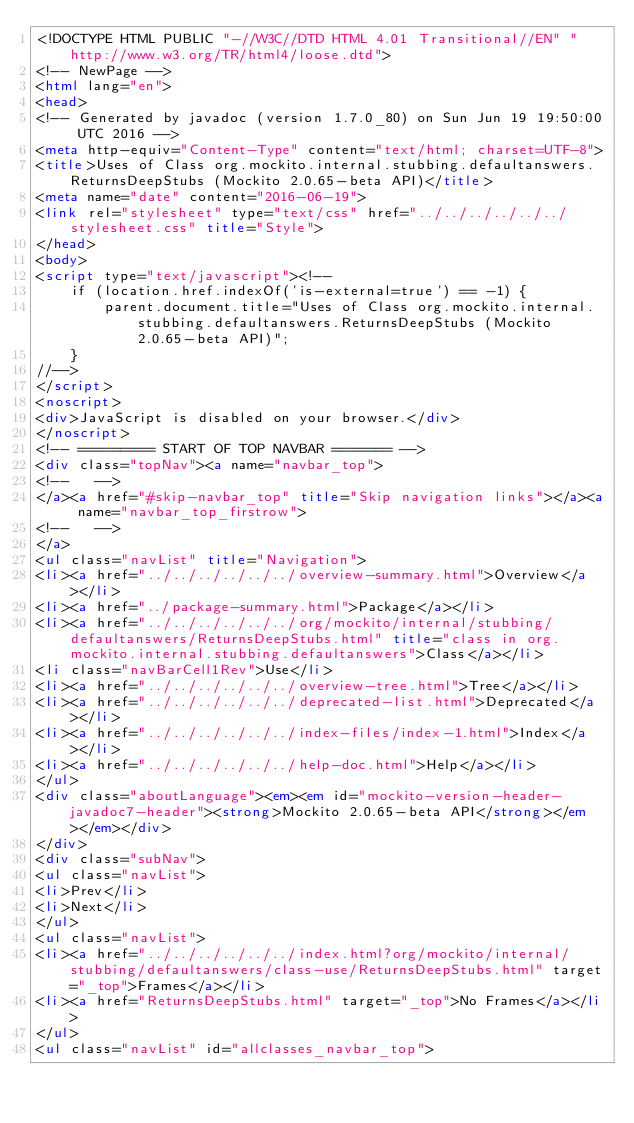Convert code to text. <code><loc_0><loc_0><loc_500><loc_500><_HTML_><!DOCTYPE HTML PUBLIC "-//W3C//DTD HTML 4.01 Transitional//EN" "http://www.w3.org/TR/html4/loose.dtd">
<!-- NewPage -->
<html lang="en">
<head>
<!-- Generated by javadoc (version 1.7.0_80) on Sun Jun 19 19:50:00 UTC 2016 -->
<meta http-equiv="Content-Type" content="text/html; charset=UTF-8">
<title>Uses of Class org.mockito.internal.stubbing.defaultanswers.ReturnsDeepStubs (Mockito 2.0.65-beta API)</title>
<meta name="date" content="2016-06-19">
<link rel="stylesheet" type="text/css" href="../../../../../../stylesheet.css" title="Style">
</head>
<body>
<script type="text/javascript"><!--
    if (location.href.indexOf('is-external=true') == -1) {
        parent.document.title="Uses of Class org.mockito.internal.stubbing.defaultanswers.ReturnsDeepStubs (Mockito 2.0.65-beta API)";
    }
//-->
</script>
<noscript>
<div>JavaScript is disabled on your browser.</div>
</noscript>
<!-- ========= START OF TOP NAVBAR ======= -->
<div class="topNav"><a name="navbar_top">
<!--   -->
</a><a href="#skip-navbar_top" title="Skip navigation links"></a><a name="navbar_top_firstrow">
<!--   -->
</a>
<ul class="navList" title="Navigation">
<li><a href="../../../../../../overview-summary.html">Overview</a></li>
<li><a href="../package-summary.html">Package</a></li>
<li><a href="../../../../../../org/mockito/internal/stubbing/defaultanswers/ReturnsDeepStubs.html" title="class in org.mockito.internal.stubbing.defaultanswers">Class</a></li>
<li class="navBarCell1Rev">Use</li>
<li><a href="../../../../../../overview-tree.html">Tree</a></li>
<li><a href="../../../../../../deprecated-list.html">Deprecated</a></li>
<li><a href="../../../../../../index-files/index-1.html">Index</a></li>
<li><a href="../../../../../../help-doc.html">Help</a></li>
</ul>
<div class="aboutLanguage"><em><em id="mockito-version-header-javadoc7-header"><strong>Mockito 2.0.65-beta API</strong></em></em></div>
</div>
<div class="subNav">
<ul class="navList">
<li>Prev</li>
<li>Next</li>
</ul>
<ul class="navList">
<li><a href="../../../../../../index.html?org/mockito/internal/stubbing/defaultanswers/class-use/ReturnsDeepStubs.html" target="_top">Frames</a></li>
<li><a href="ReturnsDeepStubs.html" target="_top">No Frames</a></li>
</ul>
<ul class="navList" id="allclasses_navbar_top"></code> 